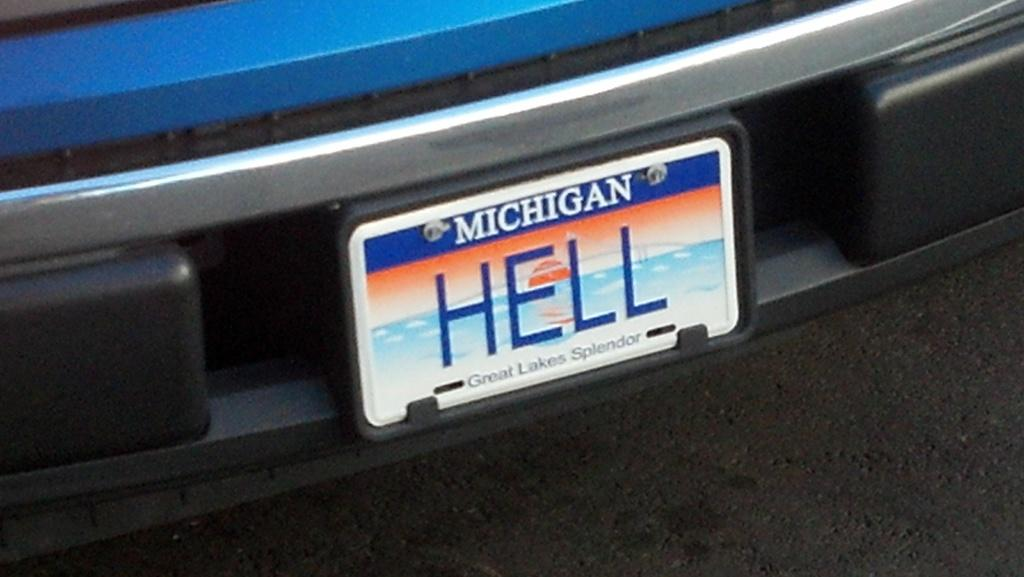<image>
Create a compact narrative representing the image presented. A close up of car license plates shows that it is Michigan plates and the motto below says "Great Lakes Splendor". 